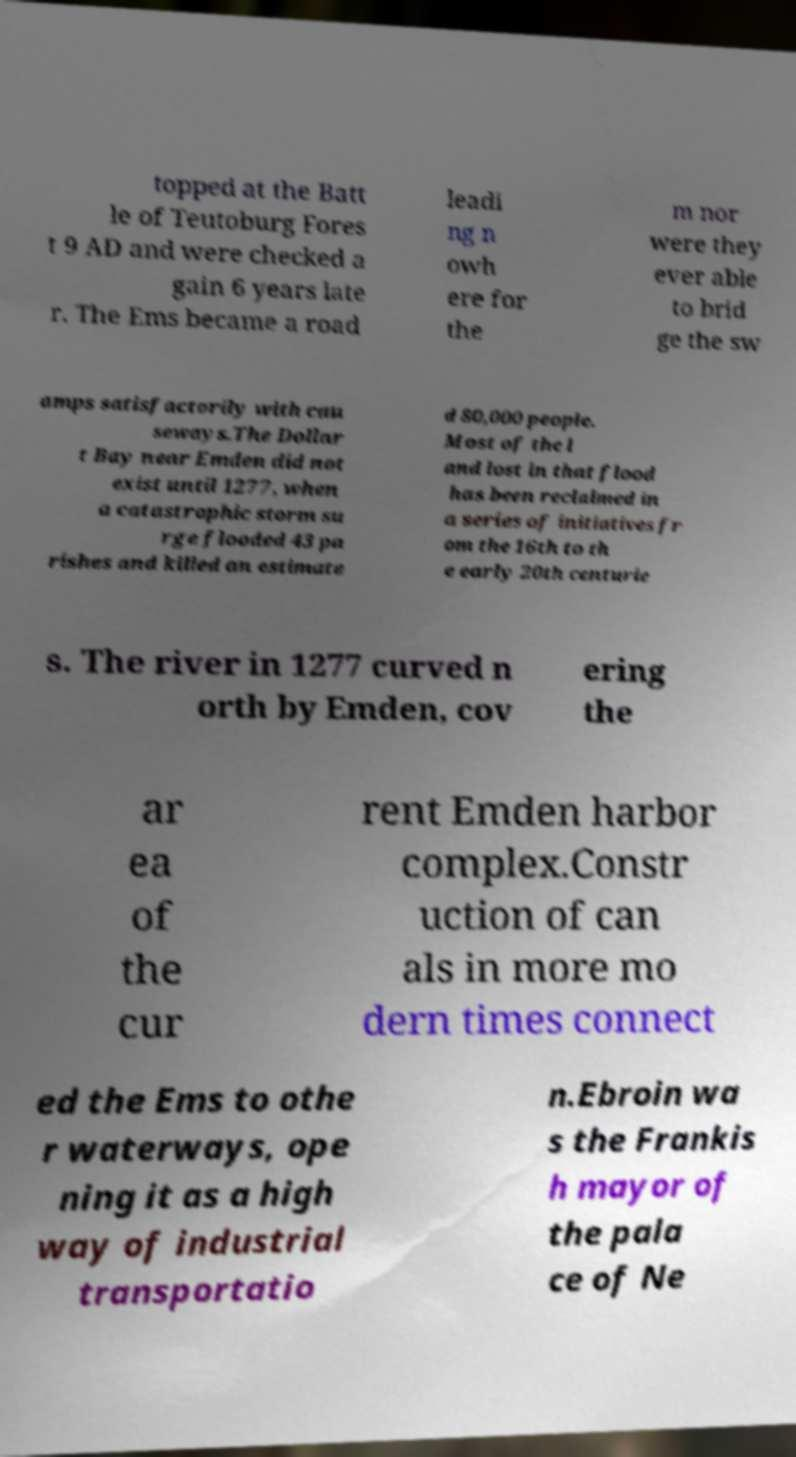There's text embedded in this image that I need extracted. Can you transcribe it verbatim? topped at the Batt le of Teutoburg Fores t 9 AD and were checked a gain 6 years late r. The Ems became a road leadi ng n owh ere for the m nor were they ever able to brid ge the sw amps satisfactorily with cau seways.The Dollar t Bay near Emden did not exist until 1277, when a catastrophic storm su rge flooded 43 pa rishes and killed an estimate d 80,000 people. Most of the l and lost in that flood has been reclaimed in a series of initiatives fr om the 16th to th e early 20th centurie s. The river in 1277 curved n orth by Emden, cov ering the ar ea of the cur rent Emden harbor complex.Constr uction of can als in more mo dern times connect ed the Ems to othe r waterways, ope ning it as a high way of industrial transportatio n.Ebroin wa s the Frankis h mayor of the pala ce of Ne 